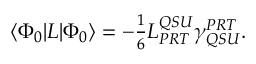Convert formula to latex. <formula><loc_0><loc_0><loc_500><loc_500>\begin{array} { r } { \langle { \Phi _ { 0 } } | L | { \Phi _ { 0 } } \rangle = - \frac { 1 } { 6 } L _ { P R T } ^ { Q S U } \gamma _ { Q S U } ^ { P R T } . } \end{array}</formula> 